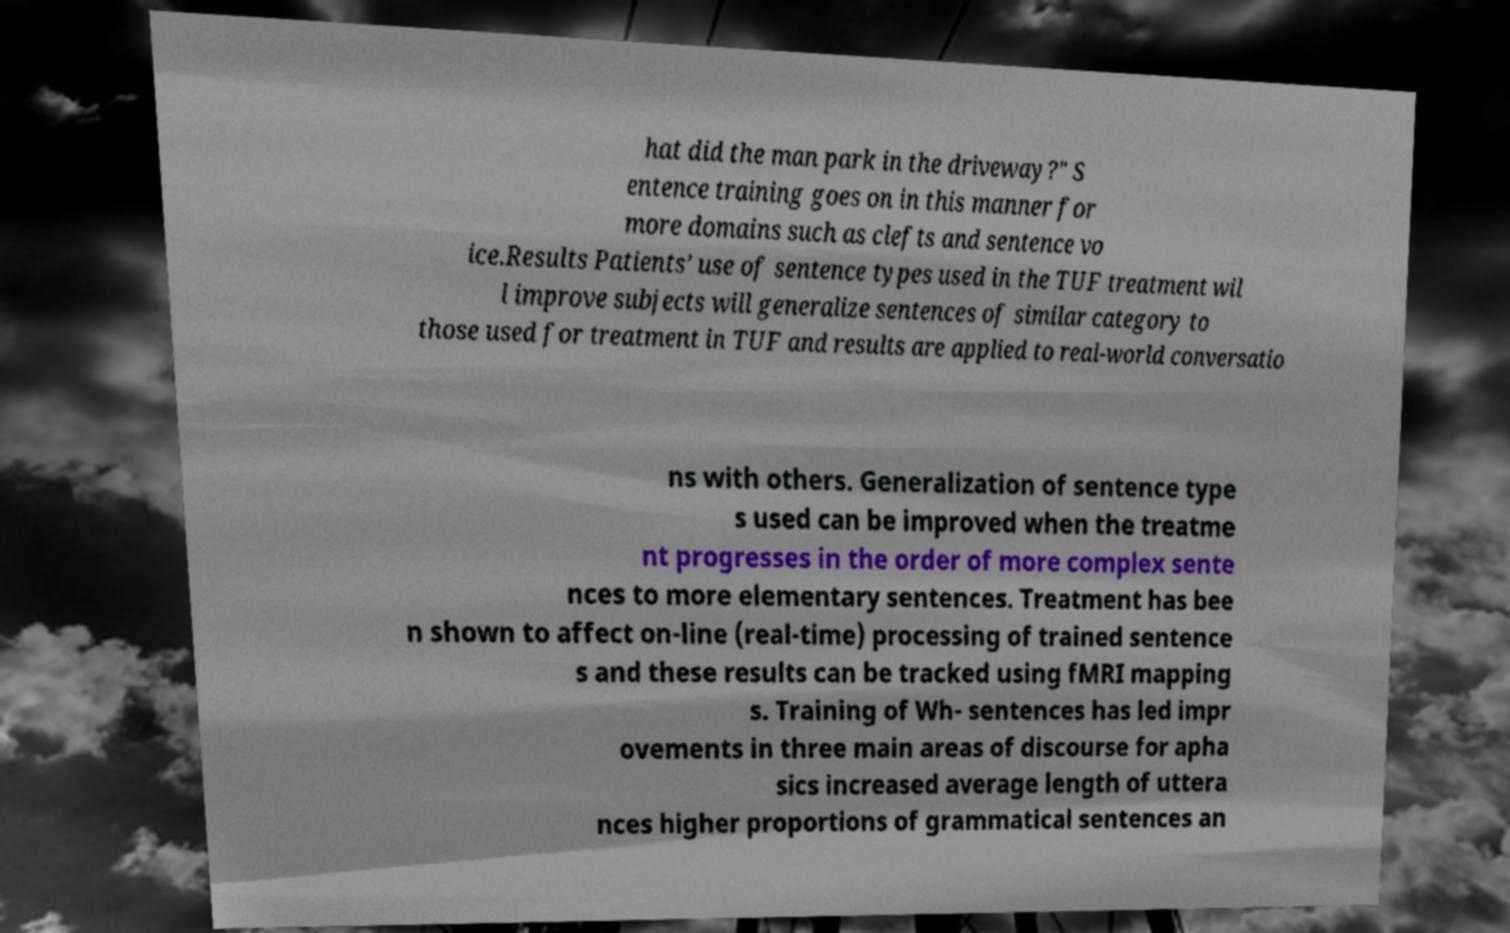What messages or text are displayed in this image? I need them in a readable, typed format. hat did the man park in the driveway?" S entence training goes on in this manner for more domains such as clefts and sentence vo ice.Results Patients’ use of sentence types used in the TUF treatment wil l improve subjects will generalize sentences of similar category to those used for treatment in TUF and results are applied to real-world conversatio ns with others. Generalization of sentence type s used can be improved when the treatme nt progresses in the order of more complex sente nces to more elementary sentences. Treatment has bee n shown to affect on-line (real-time) processing of trained sentence s and these results can be tracked using fMRI mapping s. Training of Wh- sentences has led impr ovements in three main areas of discourse for apha sics increased average length of uttera nces higher proportions of grammatical sentences an 